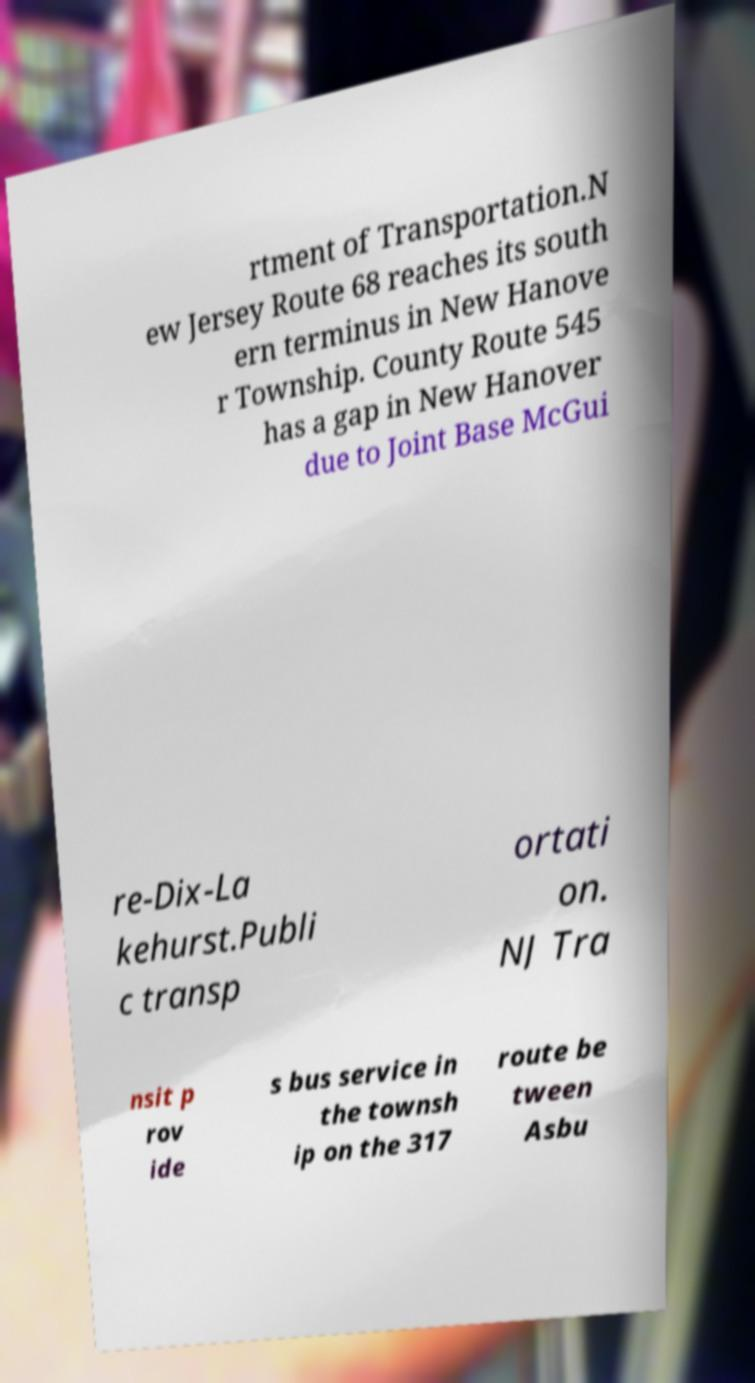Could you assist in decoding the text presented in this image and type it out clearly? rtment of Transportation.N ew Jersey Route 68 reaches its south ern terminus in New Hanove r Township. County Route 545 has a gap in New Hanover due to Joint Base McGui re-Dix-La kehurst.Publi c transp ortati on. NJ Tra nsit p rov ide s bus service in the townsh ip on the 317 route be tween Asbu 